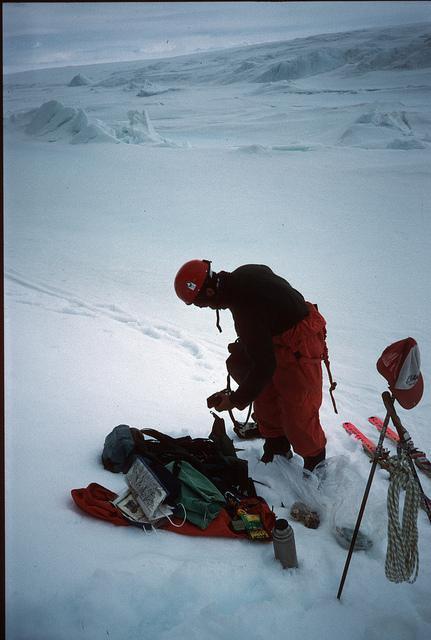How many bicycles are seen?
Give a very brief answer. 0. 